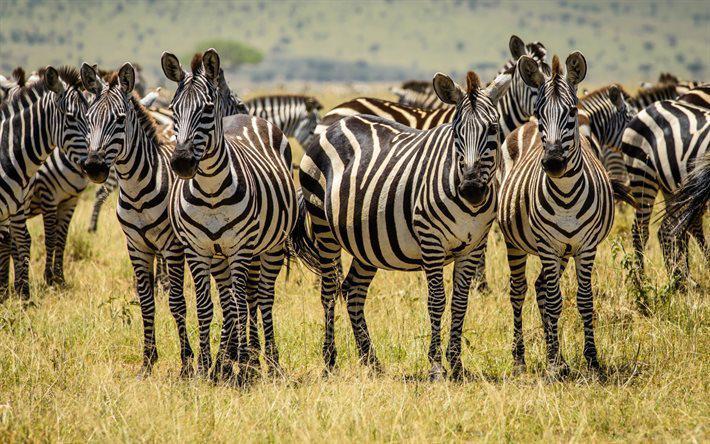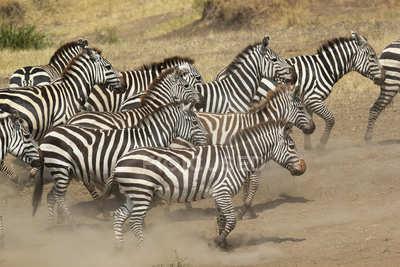The first image is the image on the left, the second image is the image on the right. Analyze the images presented: Is the assertion "One animal in one of the images is bucking." valid? Answer yes or no. No. The first image is the image on the left, the second image is the image on the right. Analyze the images presented: Is the assertion "One image shows a herd of zebras in profile all moving toward the right and stirring up the non-grass material under their feet." valid? Answer yes or no. Yes. 